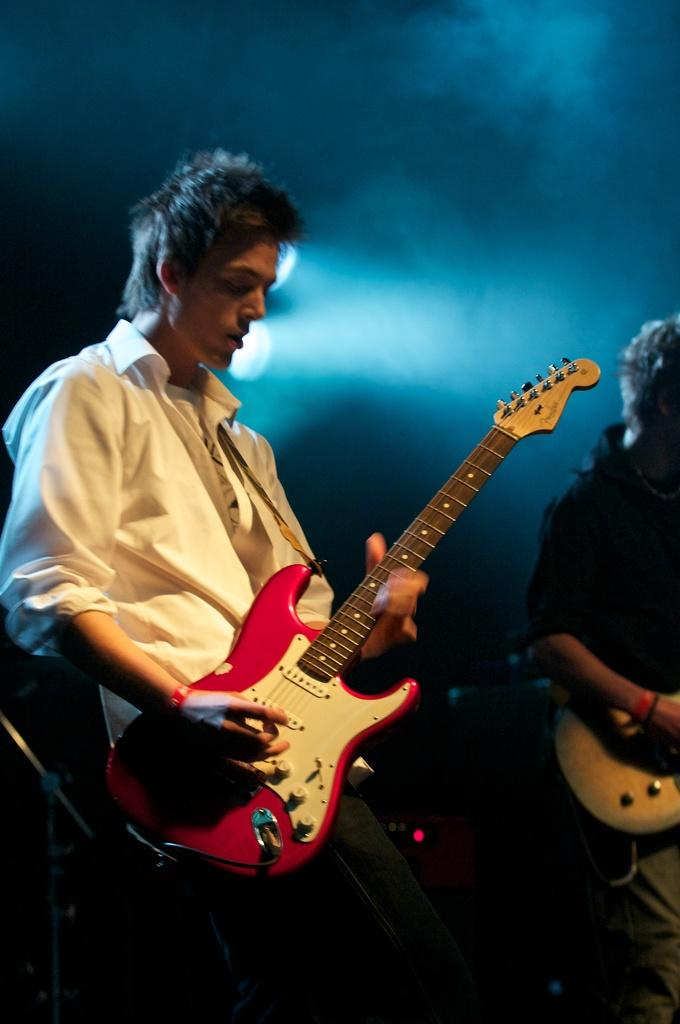What is the main activity being performed by the men in the image? The men in the image are playing guitars. How many men are playing guitars in the image? There are two men playing guitars in the image. What other object related to music performance can be seen in the image? A microphone stand is visible in the image. What type of receipt is the man holding while playing the guitar in the image? There is no receipt visible in the image; the men are focused on playing their guitars. 